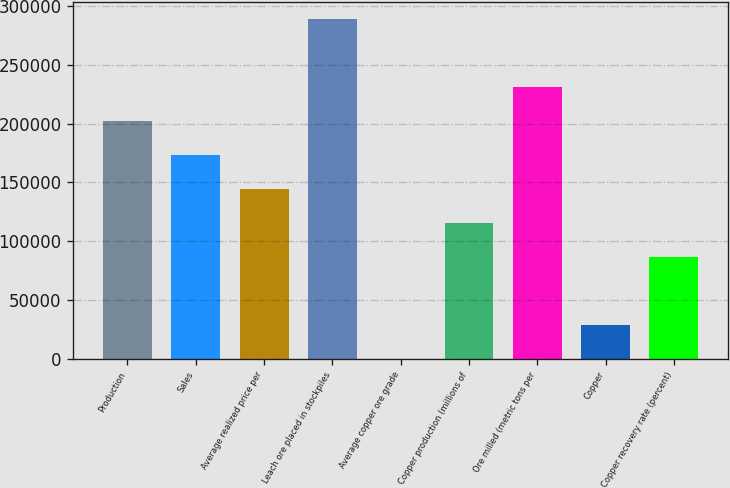Convert chart. <chart><loc_0><loc_0><loc_500><loc_500><bar_chart><fcel>Production<fcel>Sales<fcel>Average realized price per<fcel>Leach ore placed in stockpiles<fcel>Average copper ore grade<fcel>Copper production (millions of<fcel>Ore milled (metric tons per<fcel>Copper<fcel>Copper recovery rate (percent)<nl><fcel>202370<fcel>173460<fcel>144550<fcel>289100<fcel>0.43<fcel>115640<fcel>231280<fcel>28910.4<fcel>86730.3<nl></chart> 